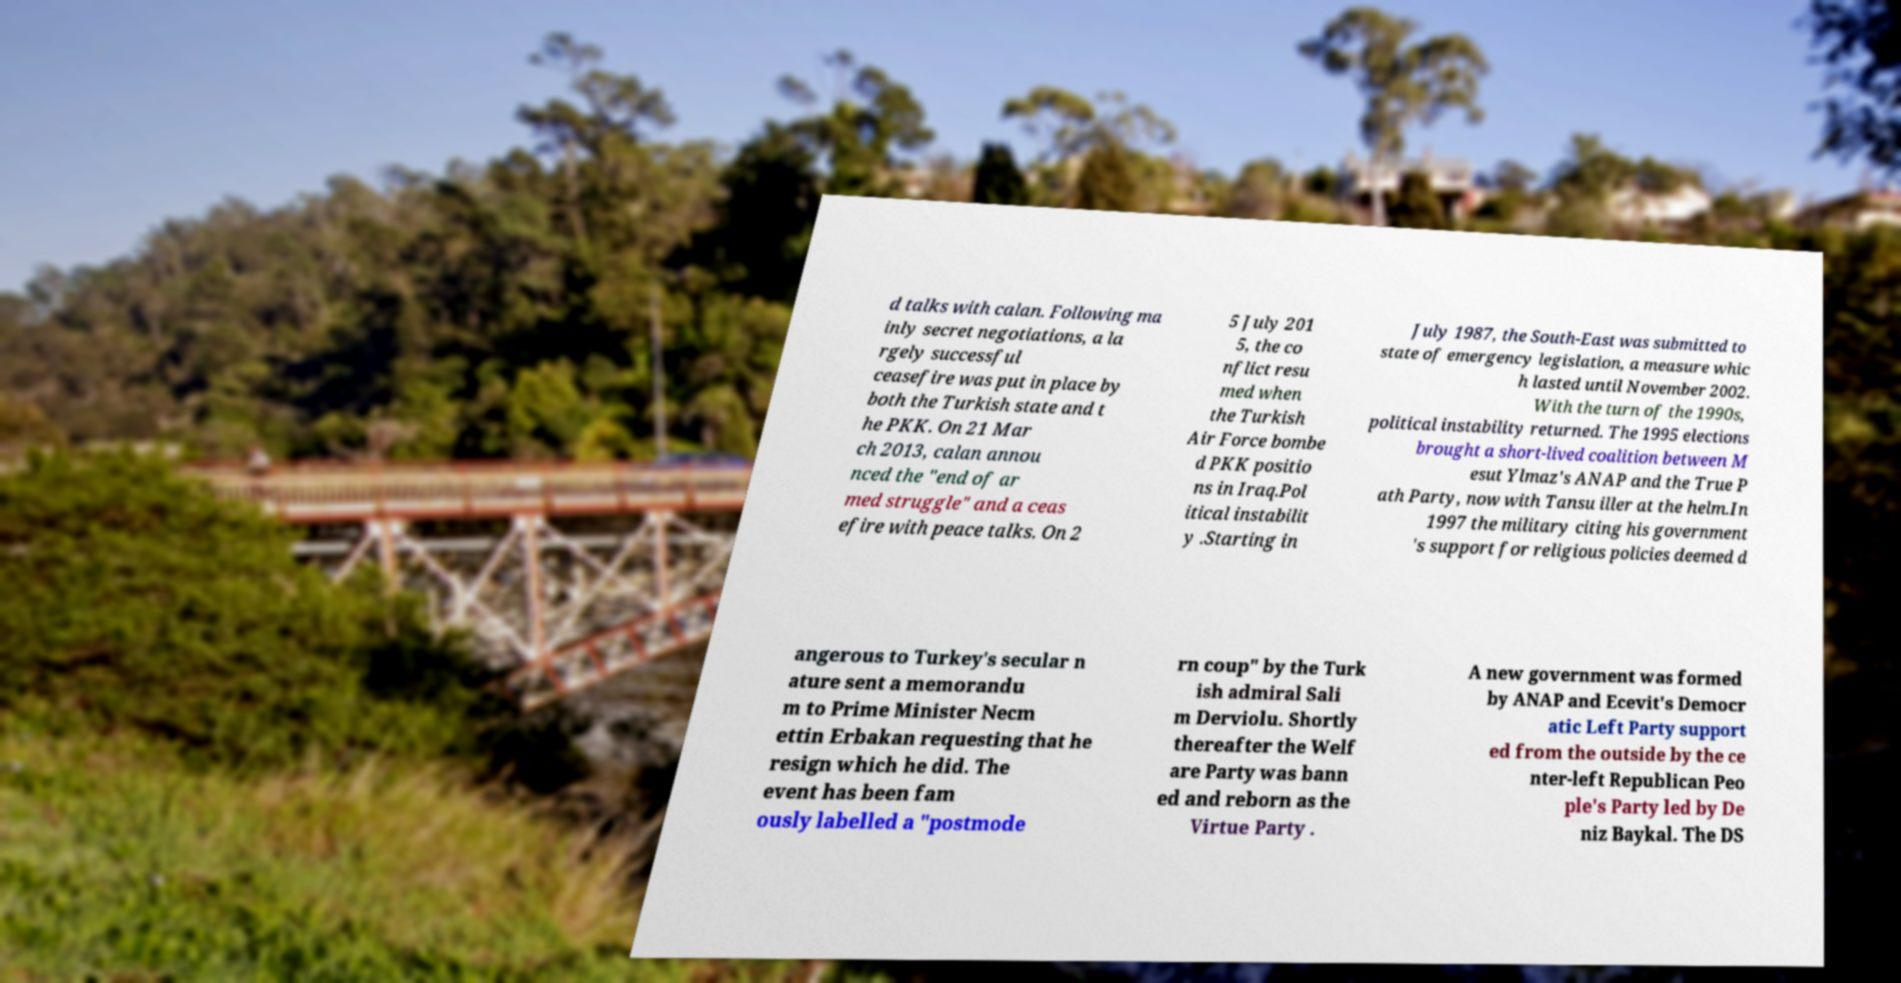Please identify and transcribe the text found in this image. d talks with calan. Following ma inly secret negotiations, a la rgely successful ceasefire was put in place by both the Turkish state and t he PKK. On 21 Mar ch 2013, calan annou nced the "end of ar med struggle" and a ceas efire with peace talks. On 2 5 July 201 5, the co nflict resu med when the Turkish Air Force bombe d PKK positio ns in Iraq.Pol itical instabilit y .Starting in July 1987, the South-East was submitted to state of emergency legislation, a measure whic h lasted until November 2002. With the turn of the 1990s, political instability returned. The 1995 elections brought a short-lived coalition between M esut Ylmaz's ANAP and the True P ath Party, now with Tansu iller at the helm.In 1997 the military citing his government 's support for religious policies deemed d angerous to Turkey's secular n ature sent a memorandu m to Prime Minister Necm ettin Erbakan requesting that he resign which he did. The event has been fam ously labelled a "postmode rn coup" by the Turk ish admiral Sali m Derviolu. Shortly thereafter the Welf are Party was bann ed and reborn as the Virtue Party . A new government was formed by ANAP and Ecevit's Democr atic Left Party support ed from the outside by the ce nter-left Republican Peo ple's Party led by De niz Baykal. The DS 